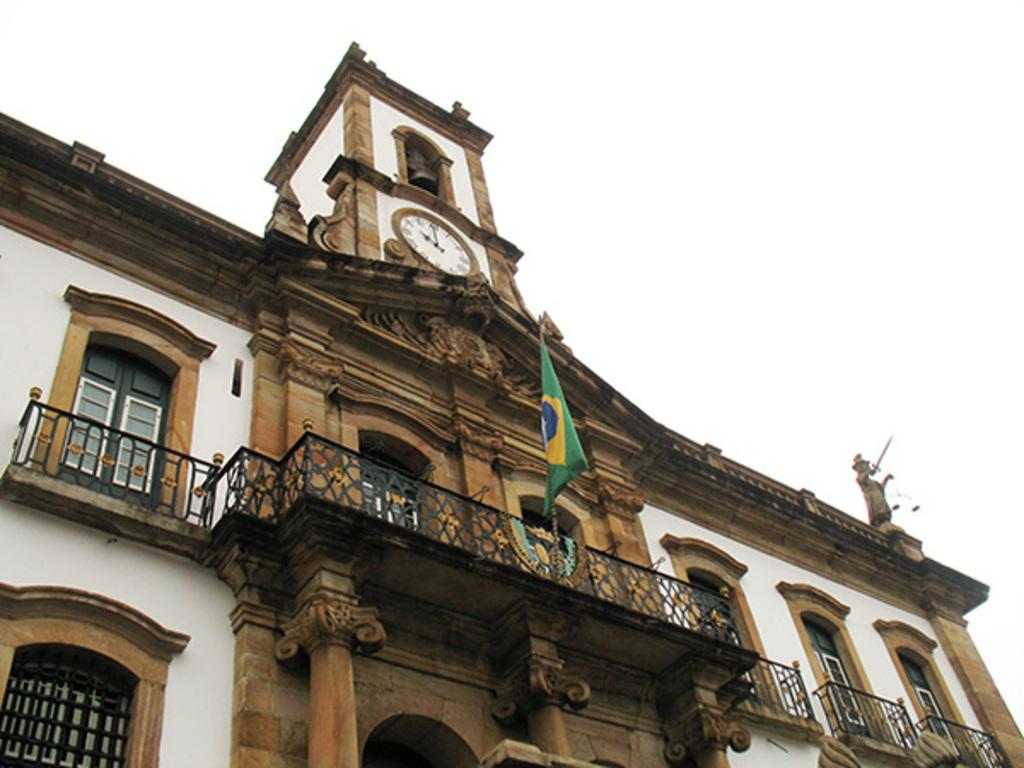What is the main subject in the middle of the image? There is a flag in the middle of the image. What type of structure can be seen in the image? There is a building in the image. What object is located at the top of the image? There is a clock at the top of the image. What type of advertisement can be seen on the building in the image? There is no advertisement present on the building in the image. What health benefits does the flag in the image provide? The flag in the image does not have any health benefits, as it is a symbol or representation. 